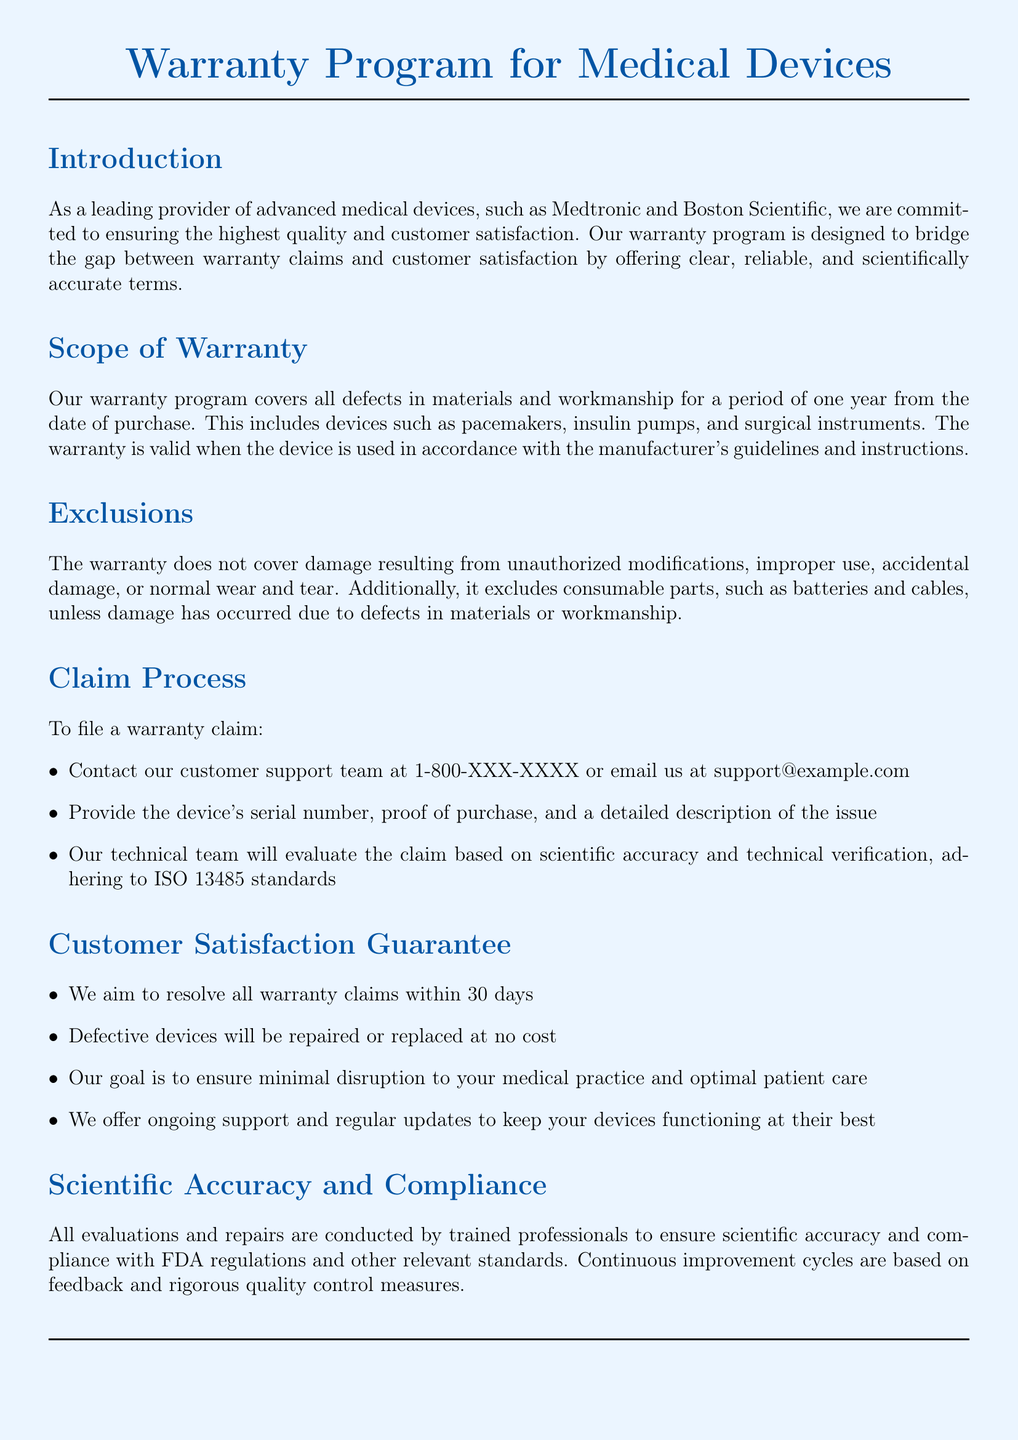What is the duration of the warranty? The document states that the warranty covers defects for a period of one year from the date of purchase.
Answer: one year Which standards do the evaluations adhere to? The warranty claim evaluations adhere to ISO 13485 standards as mentioned in the claim process.
Answer: ISO 13485 What types of devices are covered under the warranty? The document lists specific devices like pacemakers, insulin pumps, and surgical instruments that are covered by the warranty.
Answer: pacemakers, insulin pumps, surgical instruments What is the maximum time to resolve a warranty claim? The customer satisfaction guarantee section states that all claims aim to be resolved within 30 days.
Answer: 30 days What type of damage is excluded from the warranty? The document mentions that damage resulting from unauthorized modifications is one of the exclusions from the warranty coverage.
Answer: unauthorized modifications Who should be contacted to file a warranty claim? The claim process indicates that the customer support team should be contacted at 1-800-XXX-XXXX or via email.
Answer: customer support team What is the guarantee provided for defective devices? According to the document, defective devices will be repaired or replaced at no cost as part of the customer satisfaction guarantee.
Answer: no cost What do ongoing support services aim to ensure? The document states that ongoing support aims to keep devices functioning at their best for optimal patient care.
Answer: optimal patient care 